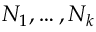<formula> <loc_0><loc_0><loc_500><loc_500>N _ { 1 } , \dots , N _ { k }</formula> 